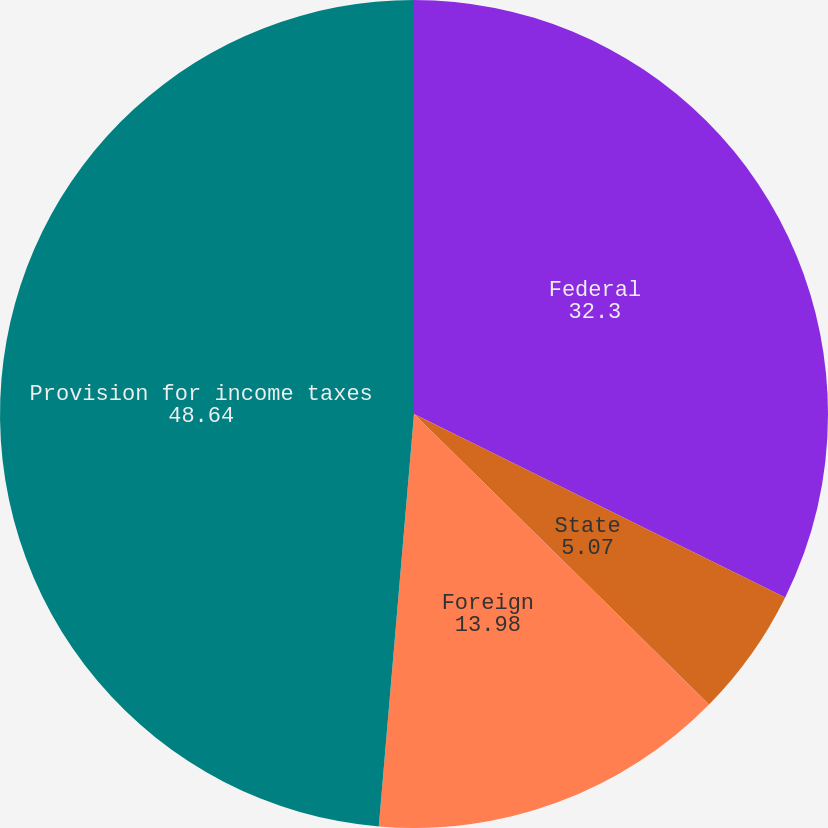Convert chart to OTSL. <chart><loc_0><loc_0><loc_500><loc_500><pie_chart><fcel>Federal<fcel>State<fcel>Foreign<fcel>Provision for income taxes<nl><fcel>32.3%<fcel>5.07%<fcel>13.98%<fcel>48.64%<nl></chart> 